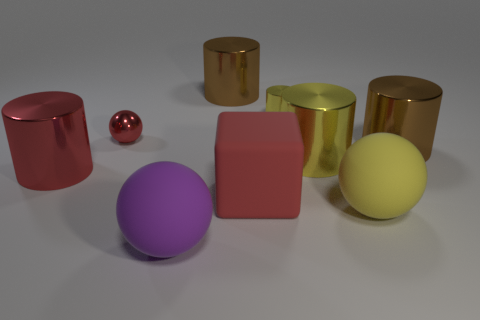Subtract all small cylinders. How many cylinders are left? 4 Subtract all blue cubes. How many yellow cylinders are left? 2 Subtract all red cylinders. How many cylinders are left? 4 Add 1 large purple objects. How many objects exist? 10 Subtract 3 cylinders. How many cylinders are left? 2 Subtract all spheres. How many objects are left? 6 Subtract 2 yellow cylinders. How many objects are left? 7 Subtract all brown cylinders. Subtract all red cubes. How many cylinders are left? 3 Subtract all purple matte spheres. Subtract all large green shiny cylinders. How many objects are left? 8 Add 9 metallic balls. How many metallic balls are left? 10 